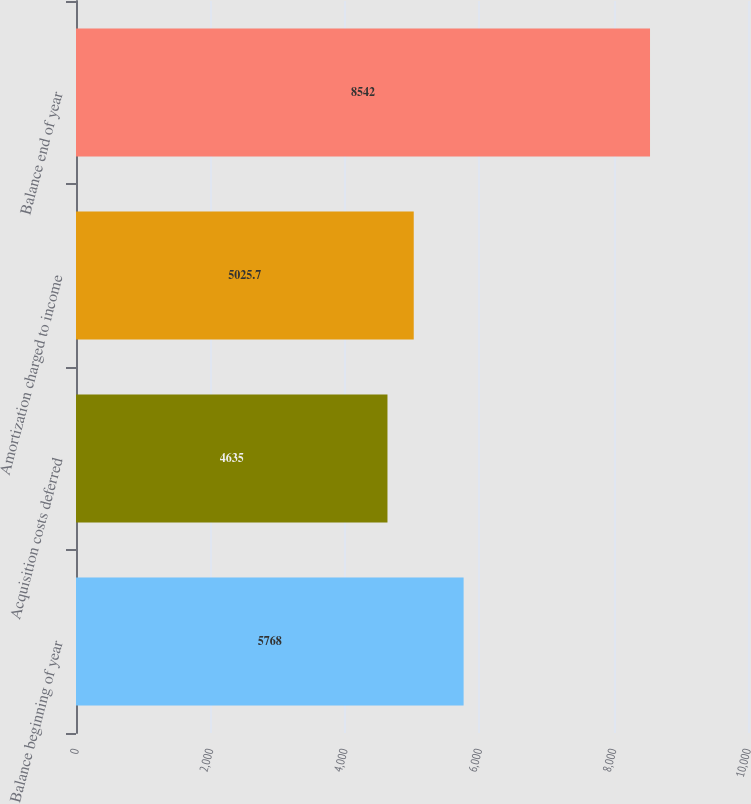<chart> <loc_0><loc_0><loc_500><loc_500><bar_chart><fcel>Balance beginning of year<fcel>Acquisition costs deferred<fcel>Amortization charged to income<fcel>Balance end of year<nl><fcel>5768<fcel>4635<fcel>5025.7<fcel>8542<nl></chart> 